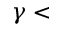<formula> <loc_0><loc_0><loc_500><loc_500>\gamma <</formula> 